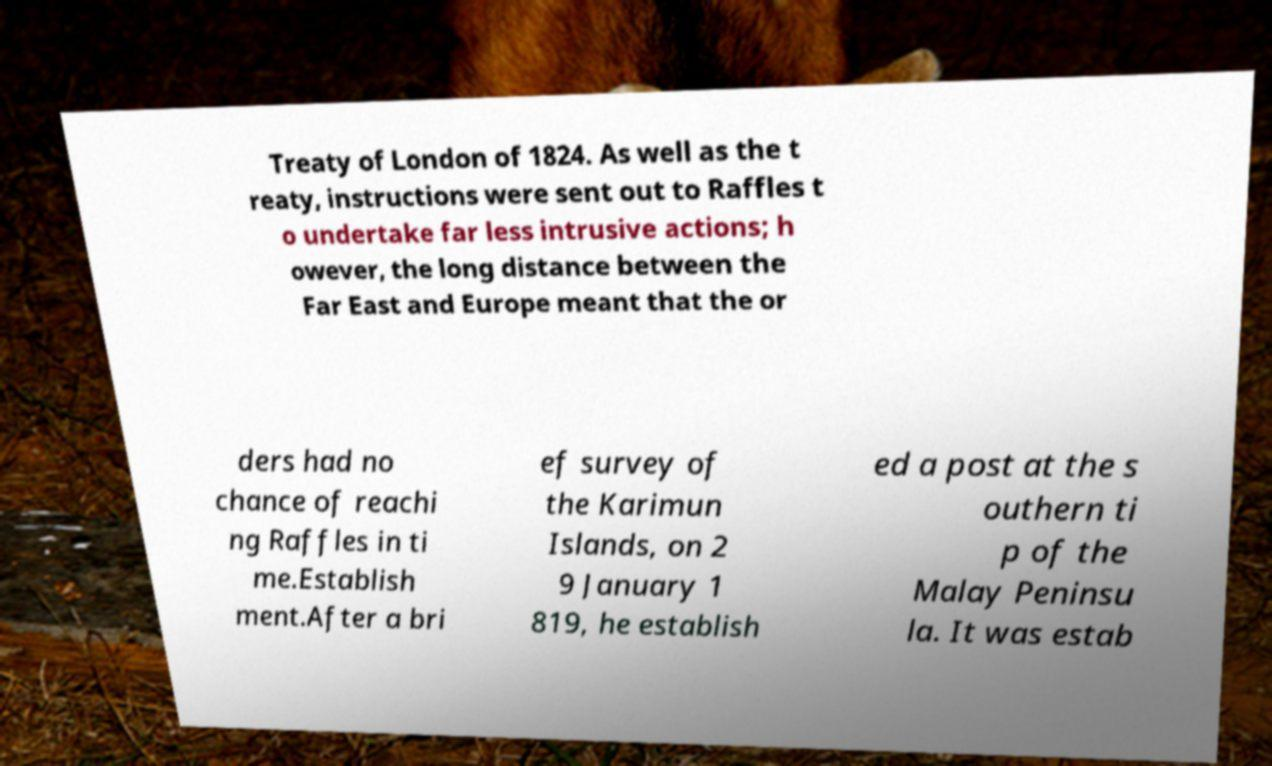Can you read and provide the text displayed in the image?This photo seems to have some interesting text. Can you extract and type it out for me? Treaty of London of 1824. As well as the t reaty, instructions were sent out to Raffles t o undertake far less intrusive actions; h owever, the long distance between the Far East and Europe meant that the or ders had no chance of reachi ng Raffles in ti me.Establish ment.After a bri ef survey of the Karimun Islands, on 2 9 January 1 819, he establish ed a post at the s outhern ti p of the Malay Peninsu la. It was estab 